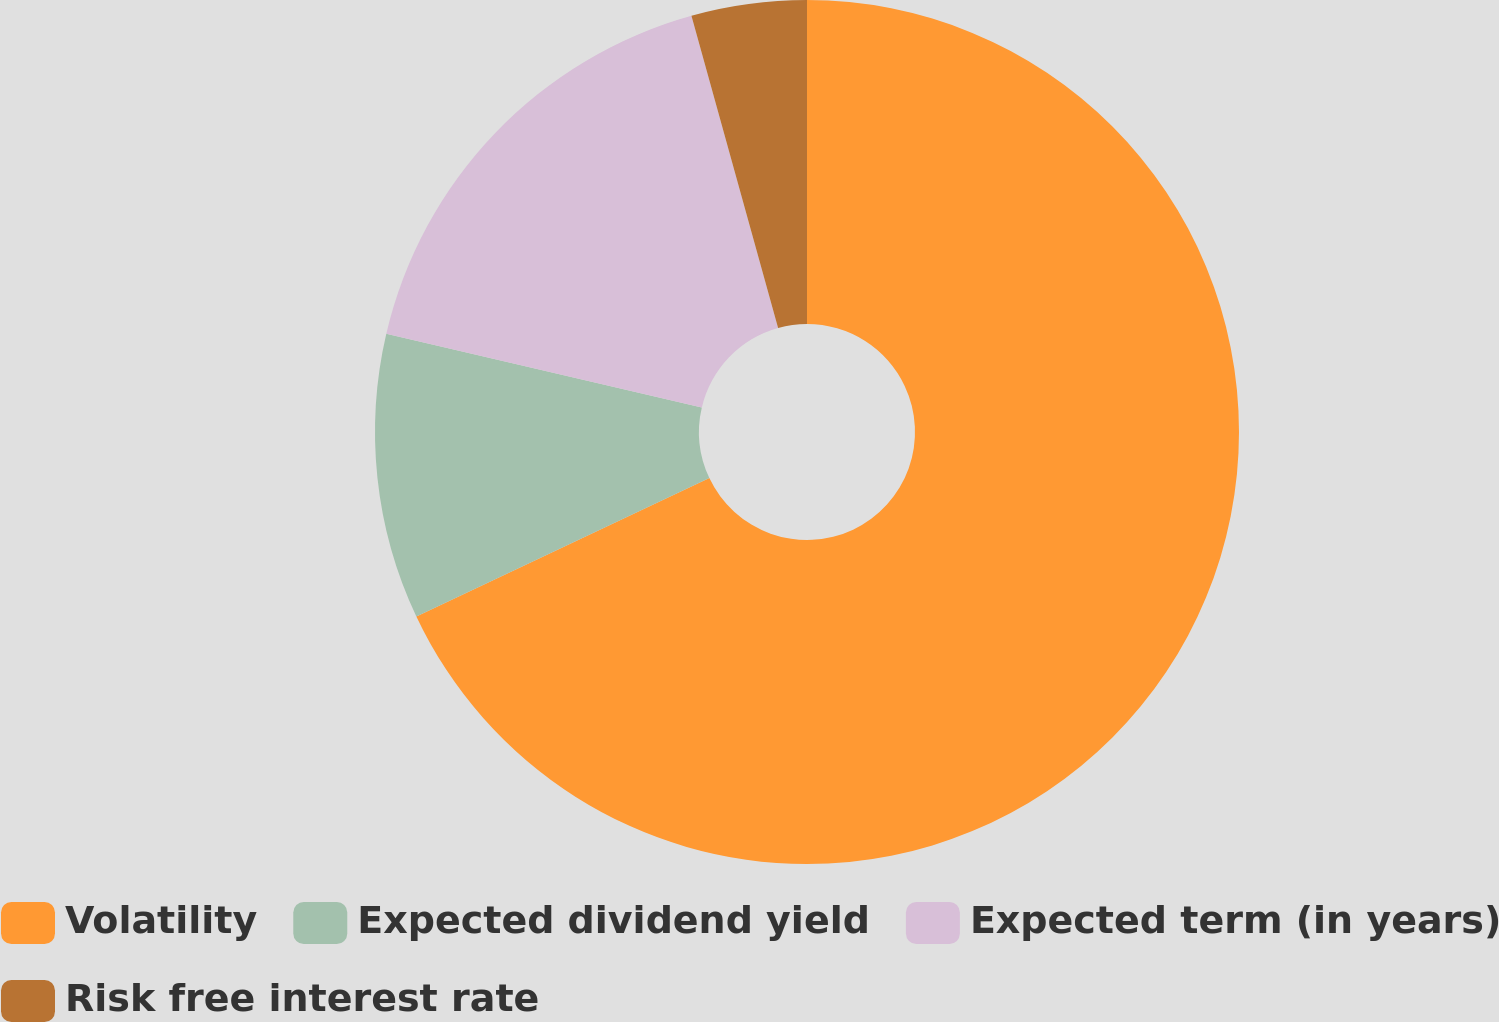Convert chart to OTSL. <chart><loc_0><loc_0><loc_500><loc_500><pie_chart><fcel>Volatility<fcel>Expected dividend yield<fcel>Expected term (in years)<fcel>Risk free interest rate<nl><fcel>67.98%<fcel>10.67%<fcel>17.04%<fcel>4.31%<nl></chart> 